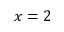Convert formula to latex. <formula><loc_0><loc_0><loc_500><loc_500>x = 2</formula> 